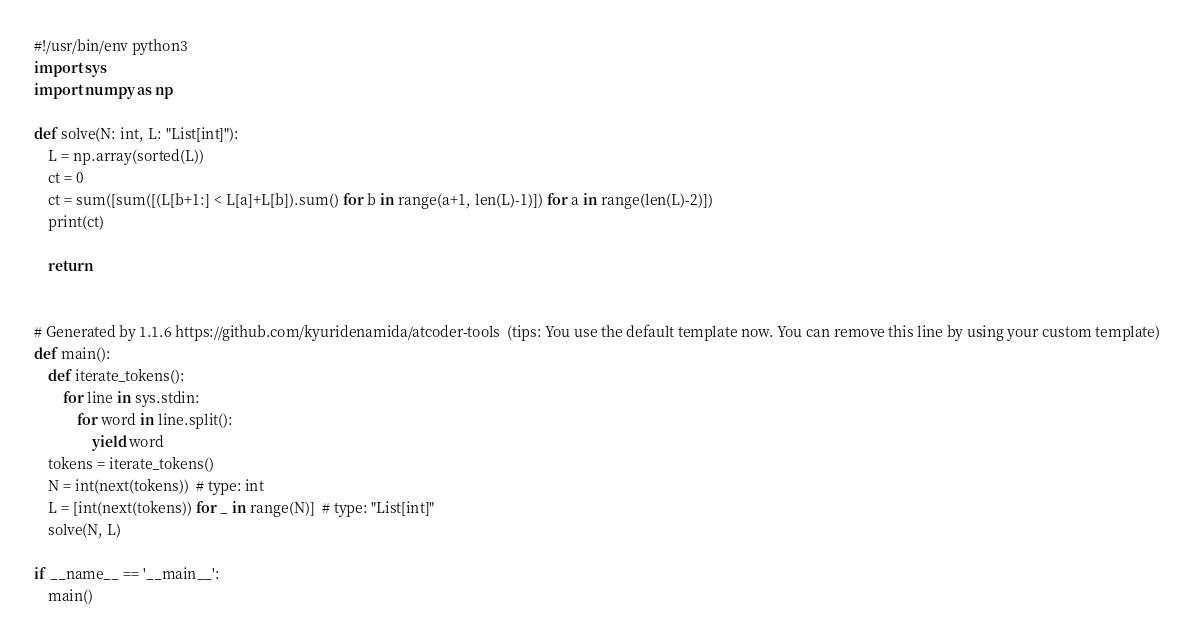Convert code to text. <code><loc_0><loc_0><loc_500><loc_500><_Python_>#!/usr/bin/env python3
import sys
import numpy as np

def solve(N: int, L: "List[int]"):
    L = np.array(sorted(L))
    ct = 0
    ct = sum([sum([(L[b+1:] < L[a]+L[b]).sum() for b in range(a+1, len(L)-1)]) for a in range(len(L)-2)])
    print(ct)

    return


# Generated by 1.1.6 https://github.com/kyuridenamida/atcoder-tools  (tips: You use the default template now. You can remove this line by using your custom template)
def main():
    def iterate_tokens():
        for line in sys.stdin:
            for word in line.split():
                yield word
    tokens = iterate_tokens()
    N = int(next(tokens))  # type: int
    L = [int(next(tokens)) for _ in range(N)]  # type: "List[int]"
    solve(N, L)

if __name__ == '__main__':
    main()
</code> 